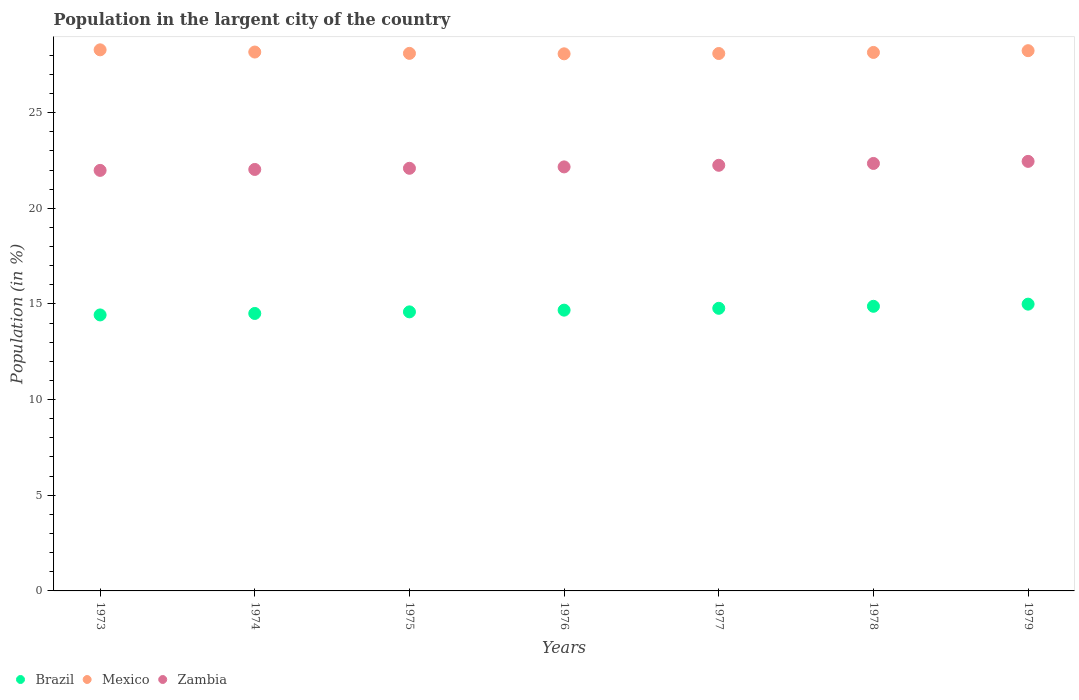Is the number of dotlines equal to the number of legend labels?
Give a very brief answer. Yes. What is the percentage of population in the largent city in Zambia in 1976?
Ensure brevity in your answer.  22.16. Across all years, what is the maximum percentage of population in the largent city in Brazil?
Provide a succinct answer. 14.99. Across all years, what is the minimum percentage of population in the largent city in Brazil?
Make the answer very short. 14.43. In which year was the percentage of population in the largent city in Mexico maximum?
Offer a very short reply. 1973. In which year was the percentage of population in the largent city in Mexico minimum?
Offer a very short reply. 1976. What is the total percentage of population in the largent city in Mexico in the graph?
Offer a very short reply. 197.09. What is the difference between the percentage of population in the largent city in Zambia in 1976 and that in 1979?
Give a very brief answer. -0.29. What is the difference between the percentage of population in the largent city in Brazil in 1973 and the percentage of population in the largent city in Mexico in 1974?
Your answer should be compact. -13.74. What is the average percentage of population in the largent city in Zambia per year?
Ensure brevity in your answer.  22.19. In the year 1976, what is the difference between the percentage of population in the largent city in Zambia and percentage of population in the largent city in Brazil?
Provide a succinct answer. 7.49. In how many years, is the percentage of population in the largent city in Mexico greater than 11 %?
Offer a terse response. 7. What is the ratio of the percentage of population in the largent city in Brazil in 1973 to that in 1975?
Ensure brevity in your answer.  0.99. Is the percentage of population in the largent city in Mexico in 1973 less than that in 1976?
Your response must be concise. No. Is the difference between the percentage of population in the largent city in Zambia in 1974 and 1979 greater than the difference between the percentage of population in the largent city in Brazil in 1974 and 1979?
Offer a terse response. Yes. What is the difference between the highest and the second highest percentage of population in the largent city in Zambia?
Provide a succinct answer. 0.11. What is the difference between the highest and the lowest percentage of population in the largent city in Brazil?
Your response must be concise. 0.56. Is the sum of the percentage of population in the largent city in Mexico in 1978 and 1979 greater than the maximum percentage of population in the largent city in Zambia across all years?
Give a very brief answer. Yes. Is it the case that in every year, the sum of the percentage of population in the largent city in Mexico and percentage of population in the largent city in Zambia  is greater than the percentage of population in the largent city in Brazil?
Give a very brief answer. Yes. Is the percentage of population in the largent city in Zambia strictly greater than the percentage of population in the largent city in Brazil over the years?
Your answer should be very brief. Yes. How many dotlines are there?
Give a very brief answer. 3. How many years are there in the graph?
Offer a very short reply. 7. Does the graph contain any zero values?
Your response must be concise. No. Where does the legend appear in the graph?
Give a very brief answer. Bottom left. How are the legend labels stacked?
Offer a terse response. Horizontal. What is the title of the graph?
Your answer should be very brief. Population in the largent city of the country. What is the label or title of the X-axis?
Your answer should be very brief. Years. What is the label or title of the Y-axis?
Provide a succinct answer. Population (in %). What is the Population (in %) in Brazil in 1973?
Offer a terse response. 14.43. What is the Population (in %) in Mexico in 1973?
Your answer should be compact. 28.28. What is the Population (in %) of Zambia in 1973?
Give a very brief answer. 21.98. What is the Population (in %) of Brazil in 1974?
Your response must be concise. 14.5. What is the Population (in %) in Mexico in 1974?
Offer a very short reply. 28.17. What is the Population (in %) in Zambia in 1974?
Ensure brevity in your answer.  22.03. What is the Population (in %) of Brazil in 1975?
Your response must be concise. 14.59. What is the Population (in %) of Mexico in 1975?
Your answer should be very brief. 28.1. What is the Population (in %) of Zambia in 1975?
Offer a very short reply. 22.09. What is the Population (in %) in Brazil in 1976?
Make the answer very short. 14.68. What is the Population (in %) of Mexico in 1976?
Ensure brevity in your answer.  28.07. What is the Population (in %) of Zambia in 1976?
Provide a succinct answer. 22.16. What is the Population (in %) of Brazil in 1977?
Provide a succinct answer. 14.77. What is the Population (in %) in Mexico in 1977?
Offer a very short reply. 28.09. What is the Population (in %) in Zambia in 1977?
Your response must be concise. 22.25. What is the Population (in %) of Brazil in 1978?
Your answer should be very brief. 14.88. What is the Population (in %) of Mexico in 1978?
Your answer should be very brief. 28.15. What is the Population (in %) of Zambia in 1978?
Your answer should be very brief. 22.34. What is the Population (in %) in Brazil in 1979?
Provide a short and direct response. 14.99. What is the Population (in %) in Mexico in 1979?
Keep it short and to the point. 28.24. What is the Population (in %) in Zambia in 1979?
Offer a terse response. 22.45. Across all years, what is the maximum Population (in %) of Brazil?
Your answer should be very brief. 14.99. Across all years, what is the maximum Population (in %) of Mexico?
Your answer should be compact. 28.28. Across all years, what is the maximum Population (in %) of Zambia?
Give a very brief answer. 22.45. Across all years, what is the minimum Population (in %) of Brazil?
Offer a very short reply. 14.43. Across all years, what is the minimum Population (in %) of Mexico?
Offer a very short reply. 28.07. Across all years, what is the minimum Population (in %) in Zambia?
Your answer should be very brief. 21.98. What is the total Population (in %) in Brazil in the graph?
Offer a very short reply. 102.83. What is the total Population (in %) in Mexico in the graph?
Give a very brief answer. 197.09. What is the total Population (in %) in Zambia in the graph?
Offer a very short reply. 155.31. What is the difference between the Population (in %) in Brazil in 1973 and that in 1974?
Provide a succinct answer. -0.08. What is the difference between the Population (in %) in Mexico in 1973 and that in 1974?
Keep it short and to the point. 0.12. What is the difference between the Population (in %) in Zambia in 1973 and that in 1974?
Offer a terse response. -0.05. What is the difference between the Population (in %) in Brazil in 1973 and that in 1975?
Your answer should be very brief. -0.16. What is the difference between the Population (in %) of Mexico in 1973 and that in 1975?
Give a very brief answer. 0.19. What is the difference between the Population (in %) in Zambia in 1973 and that in 1975?
Offer a terse response. -0.11. What is the difference between the Population (in %) of Brazil in 1973 and that in 1976?
Provide a succinct answer. -0.25. What is the difference between the Population (in %) in Mexico in 1973 and that in 1976?
Give a very brief answer. 0.21. What is the difference between the Population (in %) of Zambia in 1973 and that in 1976?
Provide a succinct answer. -0.18. What is the difference between the Population (in %) of Brazil in 1973 and that in 1977?
Offer a terse response. -0.35. What is the difference between the Population (in %) in Mexico in 1973 and that in 1977?
Your answer should be very brief. 0.19. What is the difference between the Population (in %) in Zambia in 1973 and that in 1977?
Your answer should be very brief. -0.27. What is the difference between the Population (in %) of Brazil in 1973 and that in 1978?
Your answer should be very brief. -0.45. What is the difference between the Population (in %) of Mexico in 1973 and that in 1978?
Make the answer very short. 0.14. What is the difference between the Population (in %) of Zambia in 1973 and that in 1978?
Your response must be concise. -0.36. What is the difference between the Population (in %) of Brazil in 1973 and that in 1979?
Provide a short and direct response. -0.56. What is the difference between the Population (in %) in Mexico in 1973 and that in 1979?
Offer a very short reply. 0.04. What is the difference between the Population (in %) in Zambia in 1973 and that in 1979?
Give a very brief answer. -0.47. What is the difference between the Population (in %) in Brazil in 1974 and that in 1975?
Your response must be concise. -0.08. What is the difference between the Population (in %) in Mexico in 1974 and that in 1975?
Ensure brevity in your answer.  0.07. What is the difference between the Population (in %) in Zambia in 1974 and that in 1975?
Offer a terse response. -0.06. What is the difference between the Population (in %) of Brazil in 1974 and that in 1976?
Your response must be concise. -0.17. What is the difference between the Population (in %) in Mexico in 1974 and that in 1976?
Provide a short and direct response. 0.09. What is the difference between the Population (in %) of Zambia in 1974 and that in 1976?
Make the answer very short. -0.13. What is the difference between the Population (in %) in Brazil in 1974 and that in 1977?
Offer a very short reply. -0.27. What is the difference between the Population (in %) in Mexico in 1974 and that in 1977?
Your answer should be very brief. 0.08. What is the difference between the Population (in %) of Zambia in 1974 and that in 1977?
Your response must be concise. -0.22. What is the difference between the Population (in %) in Brazil in 1974 and that in 1978?
Your response must be concise. -0.37. What is the difference between the Population (in %) of Mexico in 1974 and that in 1978?
Your answer should be compact. 0.02. What is the difference between the Population (in %) in Zambia in 1974 and that in 1978?
Offer a terse response. -0.31. What is the difference between the Population (in %) in Brazil in 1974 and that in 1979?
Keep it short and to the point. -0.49. What is the difference between the Population (in %) of Mexico in 1974 and that in 1979?
Provide a short and direct response. -0.07. What is the difference between the Population (in %) of Zambia in 1974 and that in 1979?
Keep it short and to the point. -0.42. What is the difference between the Population (in %) in Brazil in 1975 and that in 1976?
Give a very brief answer. -0.09. What is the difference between the Population (in %) in Mexico in 1975 and that in 1976?
Offer a very short reply. 0.02. What is the difference between the Population (in %) in Zambia in 1975 and that in 1976?
Your response must be concise. -0.07. What is the difference between the Population (in %) of Brazil in 1975 and that in 1977?
Your answer should be compact. -0.19. What is the difference between the Population (in %) of Mexico in 1975 and that in 1977?
Keep it short and to the point. 0.01. What is the difference between the Population (in %) of Zambia in 1975 and that in 1977?
Offer a terse response. -0.16. What is the difference between the Population (in %) of Brazil in 1975 and that in 1978?
Make the answer very short. -0.29. What is the difference between the Population (in %) of Mexico in 1975 and that in 1978?
Your answer should be very brief. -0.05. What is the difference between the Population (in %) of Zambia in 1975 and that in 1978?
Offer a very short reply. -0.25. What is the difference between the Population (in %) in Brazil in 1975 and that in 1979?
Your response must be concise. -0.4. What is the difference between the Population (in %) of Mexico in 1975 and that in 1979?
Ensure brevity in your answer.  -0.14. What is the difference between the Population (in %) in Zambia in 1975 and that in 1979?
Keep it short and to the point. -0.36. What is the difference between the Population (in %) in Brazil in 1976 and that in 1977?
Provide a short and direct response. -0.1. What is the difference between the Population (in %) in Mexico in 1976 and that in 1977?
Keep it short and to the point. -0.02. What is the difference between the Population (in %) of Zambia in 1976 and that in 1977?
Provide a short and direct response. -0.08. What is the difference between the Population (in %) of Brazil in 1976 and that in 1978?
Keep it short and to the point. -0.2. What is the difference between the Population (in %) of Mexico in 1976 and that in 1978?
Offer a very short reply. -0.07. What is the difference between the Population (in %) of Zambia in 1976 and that in 1978?
Provide a succinct answer. -0.18. What is the difference between the Population (in %) in Brazil in 1976 and that in 1979?
Keep it short and to the point. -0.31. What is the difference between the Population (in %) in Mexico in 1976 and that in 1979?
Make the answer very short. -0.16. What is the difference between the Population (in %) of Zambia in 1976 and that in 1979?
Your response must be concise. -0.29. What is the difference between the Population (in %) in Brazil in 1977 and that in 1978?
Keep it short and to the point. -0.1. What is the difference between the Population (in %) of Mexico in 1977 and that in 1978?
Offer a very short reply. -0.06. What is the difference between the Population (in %) in Zambia in 1977 and that in 1978?
Give a very brief answer. -0.1. What is the difference between the Population (in %) of Brazil in 1977 and that in 1979?
Your answer should be compact. -0.22. What is the difference between the Population (in %) of Mexico in 1977 and that in 1979?
Give a very brief answer. -0.15. What is the difference between the Population (in %) in Zambia in 1977 and that in 1979?
Offer a terse response. -0.2. What is the difference between the Population (in %) in Brazil in 1978 and that in 1979?
Give a very brief answer. -0.11. What is the difference between the Population (in %) in Mexico in 1978 and that in 1979?
Offer a terse response. -0.09. What is the difference between the Population (in %) of Zambia in 1978 and that in 1979?
Give a very brief answer. -0.11. What is the difference between the Population (in %) of Brazil in 1973 and the Population (in %) of Mexico in 1974?
Make the answer very short. -13.74. What is the difference between the Population (in %) in Brazil in 1973 and the Population (in %) in Zambia in 1974?
Provide a succinct answer. -7.6. What is the difference between the Population (in %) in Mexico in 1973 and the Population (in %) in Zambia in 1974?
Offer a very short reply. 6.25. What is the difference between the Population (in %) of Brazil in 1973 and the Population (in %) of Mexico in 1975?
Keep it short and to the point. -13.67. What is the difference between the Population (in %) in Brazil in 1973 and the Population (in %) in Zambia in 1975?
Your answer should be compact. -7.66. What is the difference between the Population (in %) in Mexico in 1973 and the Population (in %) in Zambia in 1975?
Offer a very short reply. 6.19. What is the difference between the Population (in %) in Brazil in 1973 and the Population (in %) in Mexico in 1976?
Ensure brevity in your answer.  -13.65. What is the difference between the Population (in %) in Brazil in 1973 and the Population (in %) in Zambia in 1976?
Offer a very short reply. -7.74. What is the difference between the Population (in %) in Mexico in 1973 and the Population (in %) in Zambia in 1976?
Offer a terse response. 6.12. What is the difference between the Population (in %) of Brazil in 1973 and the Population (in %) of Mexico in 1977?
Provide a short and direct response. -13.66. What is the difference between the Population (in %) of Brazil in 1973 and the Population (in %) of Zambia in 1977?
Ensure brevity in your answer.  -7.82. What is the difference between the Population (in %) in Mexico in 1973 and the Population (in %) in Zambia in 1977?
Provide a short and direct response. 6.04. What is the difference between the Population (in %) of Brazil in 1973 and the Population (in %) of Mexico in 1978?
Make the answer very short. -13.72. What is the difference between the Population (in %) of Brazil in 1973 and the Population (in %) of Zambia in 1978?
Your answer should be very brief. -7.92. What is the difference between the Population (in %) of Mexico in 1973 and the Population (in %) of Zambia in 1978?
Keep it short and to the point. 5.94. What is the difference between the Population (in %) in Brazil in 1973 and the Population (in %) in Mexico in 1979?
Provide a succinct answer. -13.81. What is the difference between the Population (in %) of Brazil in 1973 and the Population (in %) of Zambia in 1979?
Offer a terse response. -8.03. What is the difference between the Population (in %) of Mexico in 1973 and the Population (in %) of Zambia in 1979?
Your answer should be compact. 5.83. What is the difference between the Population (in %) in Brazil in 1974 and the Population (in %) in Mexico in 1975?
Ensure brevity in your answer.  -13.59. What is the difference between the Population (in %) in Brazil in 1974 and the Population (in %) in Zambia in 1975?
Offer a terse response. -7.59. What is the difference between the Population (in %) of Mexico in 1974 and the Population (in %) of Zambia in 1975?
Provide a short and direct response. 6.08. What is the difference between the Population (in %) in Brazil in 1974 and the Population (in %) in Mexico in 1976?
Make the answer very short. -13.57. What is the difference between the Population (in %) in Brazil in 1974 and the Population (in %) in Zambia in 1976?
Keep it short and to the point. -7.66. What is the difference between the Population (in %) of Mexico in 1974 and the Population (in %) of Zambia in 1976?
Ensure brevity in your answer.  6. What is the difference between the Population (in %) in Brazil in 1974 and the Population (in %) in Mexico in 1977?
Your response must be concise. -13.59. What is the difference between the Population (in %) in Brazil in 1974 and the Population (in %) in Zambia in 1977?
Your response must be concise. -7.74. What is the difference between the Population (in %) in Mexico in 1974 and the Population (in %) in Zambia in 1977?
Offer a very short reply. 5.92. What is the difference between the Population (in %) in Brazil in 1974 and the Population (in %) in Mexico in 1978?
Provide a short and direct response. -13.64. What is the difference between the Population (in %) in Brazil in 1974 and the Population (in %) in Zambia in 1978?
Provide a succinct answer. -7.84. What is the difference between the Population (in %) of Mexico in 1974 and the Population (in %) of Zambia in 1978?
Provide a short and direct response. 5.82. What is the difference between the Population (in %) in Brazil in 1974 and the Population (in %) in Mexico in 1979?
Provide a succinct answer. -13.74. What is the difference between the Population (in %) in Brazil in 1974 and the Population (in %) in Zambia in 1979?
Give a very brief answer. -7.95. What is the difference between the Population (in %) of Mexico in 1974 and the Population (in %) of Zambia in 1979?
Ensure brevity in your answer.  5.72. What is the difference between the Population (in %) in Brazil in 1975 and the Population (in %) in Mexico in 1976?
Provide a short and direct response. -13.49. What is the difference between the Population (in %) in Brazil in 1975 and the Population (in %) in Zambia in 1976?
Your answer should be very brief. -7.58. What is the difference between the Population (in %) of Mexico in 1975 and the Population (in %) of Zambia in 1976?
Keep it short and to the point. 5.93. What is the difference between the Population (in %) in Brazil in 1975 and the Population (in %) in Mexico in 1977?
Make the answer very short. -13.5. What is the difference between the Population (in %) of Brazil in 1975 and the Population (in %) of Zambia in 1977?
Your response must be concise. -7.66. What is the difference between the Population (in %) of Mexico in 1975 and the Population (in %) of Zambia in 1977?
Offer a terse response. 5.85. What is the difference between the Population (in %) of Brazil in 1975 and the Population (in %) of Mexico in 1978?
Give a very brief answer. -13.56. What is the difference between the Population (in %) in Brazil in 1975 and the Population (in %) in Zambia in 1978?
Give a very brief answer. -7.76. What is the difference between the Population (in %) of Mexico in 1975 and the Population (in %) of Zambia in 1978?
Give a very brief answer. 5.75. What is the difference between the Population (in %) of Brazil in 1975 and the Population (in %) of Mexico in 1979?
Offer a terse response. -13.65. What is the difference between the Population (in %) in Brazil in 1975 and the Population (in %) in Zambia in 1979?
Give a very brief answer. -7.87. What is the difference between the Population (in %) in Mexico in 1975 and the Population (in %) in Zambia in 1979?
Offer a very short reply. 5.64. What is the difference between the Population (in %) in Brazil in 1976 and the Population (in %) in Mexico in 1977?
Keep it short and to the point. -13.41. What is the difference between the Population (in %) of Brazil in 1976 and the Population (in %) of Zambia in 1977?
Provide a succinct answer. -7.57. What is the difference between the Population (in %) of Mexico in 1976 and the Population (in %) of Zambia in 1977?
Your answer should be compact. 5.83. What is the difference between the Population (in %) of Brazil in 1976 and the Population (in %) of Mexico in 1978?
Make the answer very short. -13.47. What is the difference between the Population (in %) of Brazil in 1976 and the Population (in %) of Zambia in 1978?
Offer a terse response. -7.67. What is the difference between the Population (in %) in Mexico in 1976 and the Population (in %) in Zambia in 1978?
Make the answer very short. 5.73. What is the difference between the Population (in %) of Brazil in 1976 and the Population (in %) of Mexico in 1979?
Provide a short and direct response. -13.56. What is the difference between the Population (in %) in Brazil in 1976 and the Population (in %) in Zambia in 1979?
Give a very brief answer. -7.78. What is the difference between the Population (in %) in Mexico in 1976 and the Population (in %) in Zambia in 1979?
Your answer should be very brief. 5.62. What is the difference between the Population (in %) in Brazil in 1977 and the Population (in %) in Mexico in 1978?
Keep it short and to the point. -13.37. What is the difference between the Population (in %) in Brazil in 1977 and the Population (in %) in Zambia in 1978?
Provide a succinct answer. -7.57. What is the difference between the Population (in %) in Mexico in 1977 and the Population (in %) in Zambia in 1978?
Offer a terse response. 5.75. What is the difference between the Population (in %) of Brazil in 1977 and the Population (in %) of Mexico in 1979?
Your response must be concise. -13.47. What is the difference between the Population (in %) of Brazil in 1977 and the Population (in %) of Zambia in 1979?
Provide a succinct answer. -7.68. What is the difference between the Population (in %) of Mexico in 1977 and the Population (in %) of Zambia in 1979?
Your response must be concise. 5.64. What is the difference between the Population (in %) of Brazil in 1978 and the Population (in %) of Mexico in 1979?
Offer a very short reply. -13.36. What is the difference between the Population (in %) of Brazil in 1978 and the Population (in %) of Zambia in 1979?
Ensure brevity in your answer.  -7.58. What is the difference between the Population (in %) of Mexico in 1978 and the Population (in %) of Zambia in 1979?
Offer a very short reply. 5.69. What is the average Population (in %) of Brazil per year?
Offer a terse response. 14.69. What is the average Population (in %) in Mexico per year?
Offer a very short reply. 28.16. What is the average Population (in %) of Zambia per year?
Make the answer very short. 22.19. In the year 1973, what is the difference between the Population (in %) in Brazil and Population (in %) in Mexico?
Offer a terse response. -13.86. In the year 1973, what is the difference between the Population (in %) of Brazil and Population (in %) of Zambia?
Provide a succinct answer. -7.55. In the year 1973, what is the difference between the Population (in %) of Mexico and Population (in %) of Zambia?
Your response must be concise. 6.3. In the year 1974, what is the difference between the Population (in %) in Brazil and Population (in %) in Mexico?
Keep it short and to the point. -13.66. In the year 1974, what is the difference between the Population (in %) in Brazil and Population (in %) in Zambia?
Offer a very short reply. -7.53. In the year 1974, what is the difference between the Population (in %) in Mexico and Population (in %) in Zambia?
Make the answer very short. 6.14. In the year 1975, what is the difference between the Population (in %) of Brazil and Population (in %) of Mexico?
Your answer should be compact. -13.51. In the year 1975, what is the difference between the Population (in %) in Brazil and Population (in %) in Zambia?
Offer a very short reply. -7.5. In the year 1975, what is the difference between the Population (in %) in Mexico and Population (in %) in Zambia?
Ensure brevity in your answer.  6.01. In the year 1976, what is the difference between the Population (in %) of Brazil and Population (in %) of Mexico?
Keep it short and to the point. -13.4. In the year 1976, what is the difference between the Population (in %) in Brazil and Population (in %) in Zambia?
Provide a succinct answer. -7.49. In the year 1976, what is the difference between the Population (in %) in Mexico and Population (in %) in Zambia?
Make the answer very short. 5.91. In the year 1977, what is the difference between the Population (in %) of Brazil and Population (in %) of Mexico?
Make the answer very short. -13.32. In the year 1977, what is the difference between the Population (in %) of Brazil and Population (in %) of Zambia?
Give a very brief answer. -7.47. In the year 1977, what is the difference between the Population (in %) in Mexico and Population (in %) in Zambia?
Offer a very short reply. 5.84. In the year 1978, what is the difference between the Population (in %) in Brazil and Population (in %) in Mexico?
Your answer should be compact. -13.27. In the year 1978, what is the difference between the Population (in %) of Brazil and Population (in %) of Zambia?
Provide a succinct answer. -7.47. In the year 1978, what is the difference between the Population (in %) of Mexico and Population (in %) of Zambia?
Offer a terse response. 5.8. In the year 1979, what is the difference between the Population (in %) in Brazil and Population (in %) in Mexico?
Keep it short and to the point. -13.25. In the year 1979, what is the difference between the Population (in %) in Brazil and Population (in %) in Zambia?
Keep it short and to the point. -7.46. In the year 1979, what is the difference between the Population (in %) of Mexico and Population (in %) of Zambia?
Make the answer very short. 5.79. What is the ratio of the Population (in %) of Brazil in 1973 to that in 1974?
Give a very brief answer. 0.99. What is the ratio of the Population (in %) of Mexico in 1973 to that in 1974?
Give a very brief answer. 1. What is the ratio of the Population (in %) in Brazil in 1973 to that in 1975?
Your answer should be very brief. 0.99. What is the ratio of the Population (in %) in Mexico in 1973 to that in 1975?
Provide a succinct answer. 1.01. What is the ratio of the Population (in %) in Zambia in 1973 to that in 1975?
Provide a short and direct response. 0.99. What is the ratio of the Population (in %) in Mexico in 1973 to that in 1976?
Give a very brief answer. 1.01. What is the ratio of the Population (in %) of Brazil in 1973 to that in 1977?
Your answer should be very brief. 0.98. What is the ratio of the Population (in %) of Mexico in 1973 to that in 1977?
Ensure brevity in your answer.  1.01. What is the ratio of the Population (in %) of Brazil in 1973 to that in 1978?
Make the answer very short. 0.97. What is the ratio of the Population (in %) of Mexico in 1973 to that in 1978?
Make the answer very short. 1. What is the ratio of the Population (in %) of Zambia in 1973 to that in 1978?
Your answer should be compact. 0.98. What is the ratio of the Population (in %) in Brazil in 1973 to that in 1979?
Provide a succinct answer. 0.96. What is the ratio of the Population (in %) of Mexico in 1973 to that in 1979?
Offer a very short reply. 1. What is the ratio of the Population (in %) of Zambia in 1973 to that in 1979?
Keep it short and to the point. 0.98. What is the ratio of the Population (in %) of Brazil in 1974 to that in 1975?
Your response must be concise. 0.99. What is the ratio of the Population (in %) in Brazil in 1974 to that in 1976?
Your response must be concise. 0.99. What is the ratio of the Population (in %) in Mexico in 1974 to that in 1976?
Offer a very short reply. 1. What is the ratio of the Population (in %) of Brazil in 1974 to that in 1977?
Your response must be concise. 0.98. What is the ratio of the Population (in %) of Zambia in 1974 to that in 1977?
Offer a very short reply. 0.99. What is the ratio of the Population (in %) of Brazil in 1974 to that in 1978?
Make the answer very short. 0.97. What is the ratio of the Population (in %) in Mexico in 1974 to that in 1978?
Your answer should be compact. 1. What is the ratio of the Population (in %) in Brazil in 1974 to that in 1979?
Your response must be concise. 0.97. What is the ratio of the Population (in %) of Zambia in 1974 to that in 1979?
Your response must be concise. 0.98. What is the ratio of the Population (in %) of Mexico in 1975 to that in 1976?
Your answer should be compact. 1. What is the ratio of the Population (in %) of Brazil in 1975 to that in 1977?
Your answer should be very brief. 0.99. What is the ratio of the Population (in %) in Mexico in 1975 to that in 1977?
Provide a succinct answer. 1. What is the ratio of the Population (in %) in Zambia in 1975 to that in 1977?
Give a very brief answer. 0.99. What is the ratio of the Population (in %) of Brazil in 1975 to that in 1978?
Offer a very short reply. 0.98. What is the ratio of the Population (in %) of Mexico in 1975 to that in 1978?
Your answer should be very brief. 1. What is the ratio of the Population (in %) in Brazil in 1975 to that in 1979?
Your response must be concise. 0.97. What is the ratio of the Population (in %) of Zambia in 1975 to that in 1979?
Keep it short and to the point. 0.98. What is the ratio of the Population (in %) in Mexico in 1976 to that in 1977?
Provide a short and direct response. 1. What is the ratio of the Population (in %) in Brazil in 1976 to that in 1978?
Provide a short and direct response. 0.99. What is the ratio of the Population (in %) in Brazil in 1976 to that in 1979?
Provide a short and direct response. 0.98. What is the ratio of the Population (in %) of Mexico in 1976 to that in 1979?
Provide a succinct answer. 0.99. What is the ratio of the Population (in %) of Zambia in 1976 to that in 1979?
Your answer should be very brief. 0.99. What is the ratio of the Population (in %) in Mexico in 1977 to that in 1978?
Your answer should be very brief. 1. What is the ratio of the Population (in %) of Brazil in 1977 to that in 1979?
Your answer should be compact. 0.99. What is the ratio of the Population (in %) of Mexico in 1977 to that in 1979?
Your answer should be compact. 0.99. What is the ratio of the Population (in %) of Zambia in 1977 to that in 1979?
Give a very brief answer. 0.99. What is the ratio of the Population (in %) in Zambia in 1978 to that in 1979?
Your answer should be very brief. 1. What is the difference between the highest and the second highest Population (in %) of Brazil?
Your answer should be compact. 0.11. What is the difference between the highest and the second highest Population (in %) of Mexico?
Your answer should be very brief. 0.04. What is the difference between the highest and the second highest Population (in %) in Zambia?
Your answer should be compact. 0.11. What is the difference between the highest and the lowest Population (in %) in Brazil?
Make the answer very short. 0.56. What is the difference between the highest and the lowest Population (in %) of Mexico?
Offer a terse response. 0.21. What is the difference between the highest and the lowest Population (in %) of Zambia?
Keep it short and to the point. 0.47. 